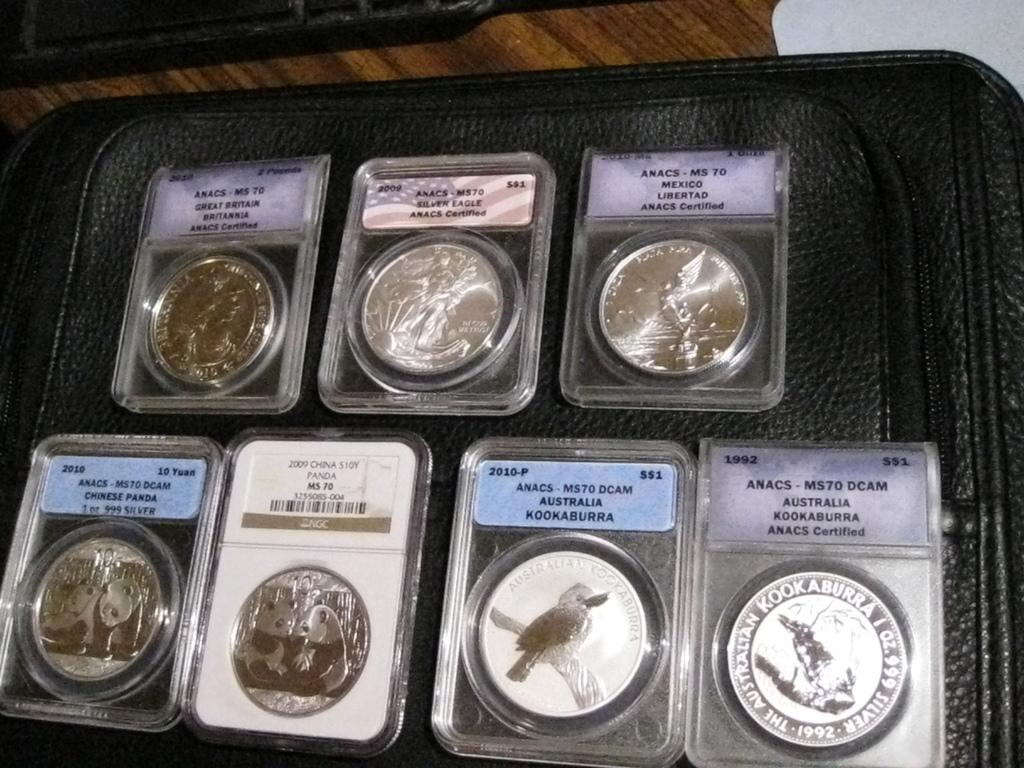<image>
Offer a succinct explanation of the picture presented. Coins from Australia, Mexico, America, and Great Britain are on display in protective cases. 